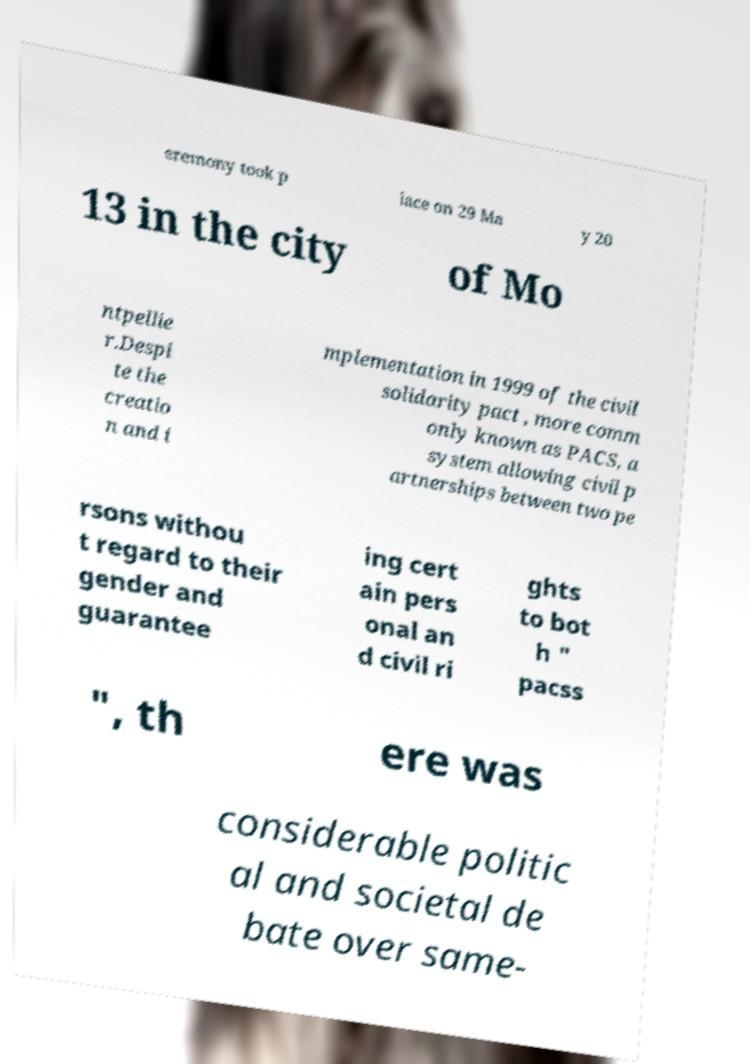Could you assist in decoding the text presented in this image and type it out clearly? eremony took p lace on 29 Ma y 20 13 in the city of Mo ntpellie r.Despi te the creatio n and i mplementation in 1999 of the civil solidarity pact , more comm only known as PACS, a system allowing civil p artnerships between two pe rsons withou t regard to their gender and guarantee ing cert ain pers onal an d civil ri ghts to bot h " pacss ", th ere was considerable politic al and societal de bate over same- 